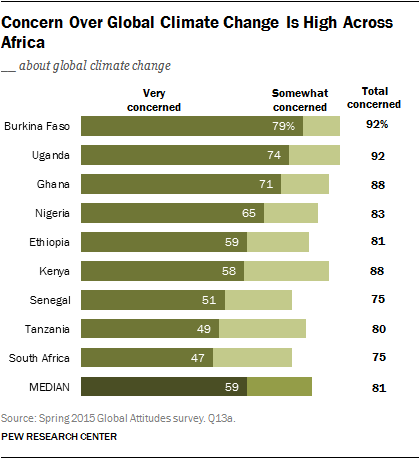Outline some significant characteristics in this image. The share of those who are very concerned about climate change in Nigeria is 65%. The median of the total number of people concerned about climate change in Uganda and Ghana is 90. 